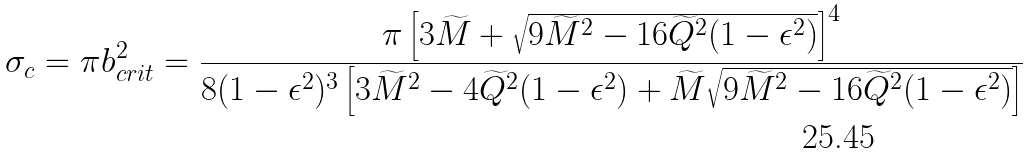<formula> <loc_0><loc_0><loc_500><loc_500>\sigma _ { c } = \pi b _ { c r i t } ^ { 2 } = \frac { \pi \left [ 3 \widetilde { M } + \sqrt { 9 \widetilde { M } ^ { 2 } - 1 6 \widetilde { Q } ^ { 2 } ( 1 - \epsilon ^ { 2 } ) } \right ] ^ { 4 } } { 8 ( 1 - \epsilon ^ { 2 } ) ^ { 3 } \left [ 3 \widetilde { M } ^ { 2 } - 4 \widetilde { Q } ^ { 2 } ( 1 - \epsilon ^ { 2 } ) + \widetilde { M } \sqrt { 9 \widetilde { M } ^ { 2 } - 1 6 \widetilde { Q } ^ { 2 } ( 1 - \epsilon ^ { 2 } ) } \right ] }</formula> 